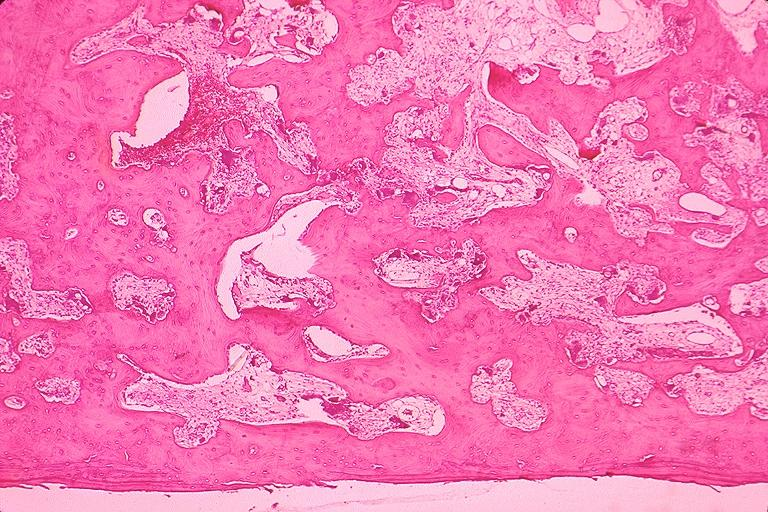where is this?
Answer the question using a single word or phrase. Oral 